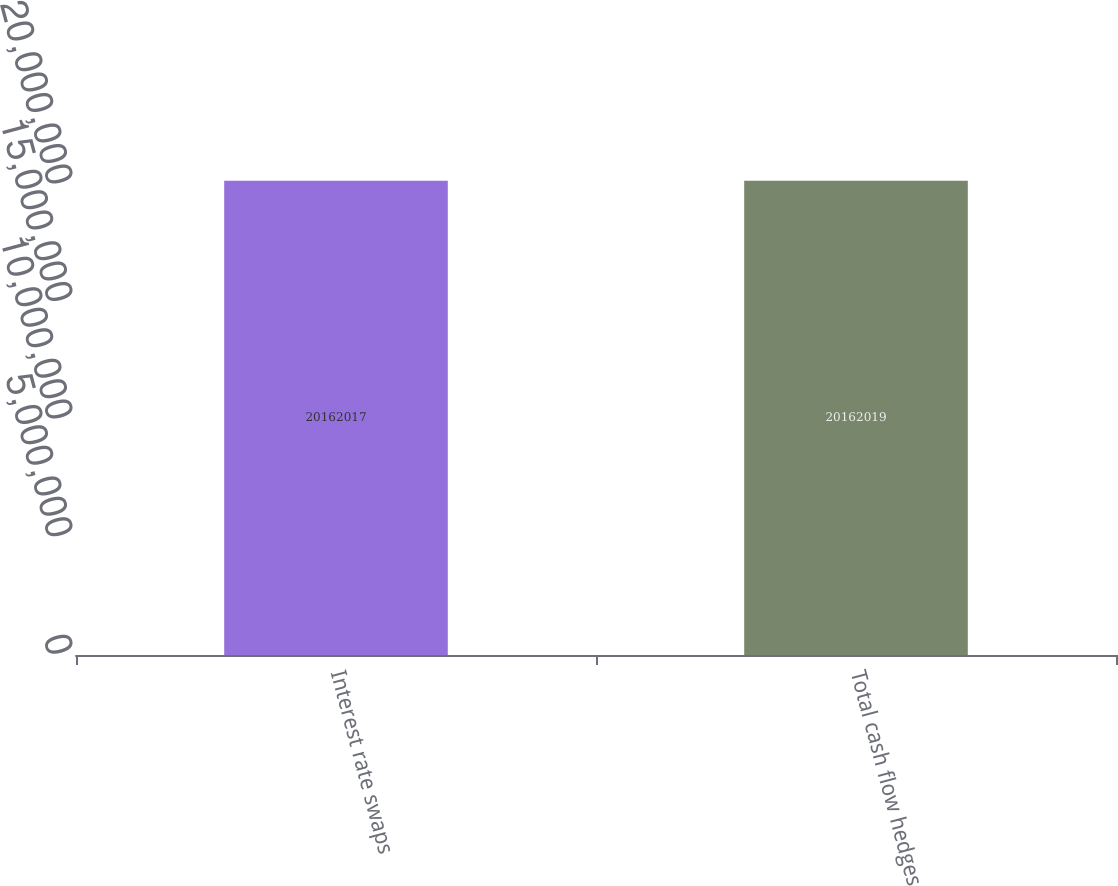<chart> <loc_0><loc_0><loc_500><loc_500><bar_chart><fcel>Interest rate swaps<fcel>Total cash flow hedges<nl><fcel>2.0162e+07<fcel>2.0162e+07<nl></chart> 